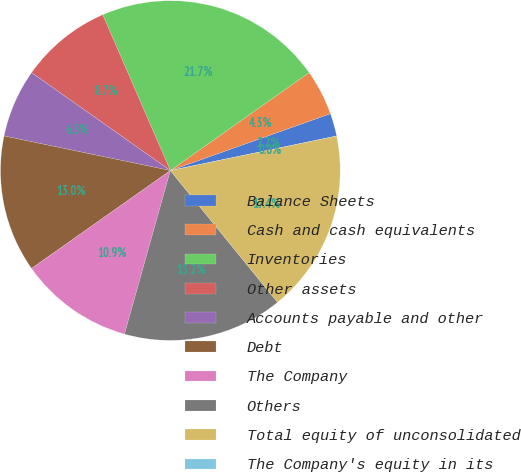<chart> <loc_0><loc_0><loc_500><loc_500><pie_chart><fcel>Balance Sheets<fcel>Cash and cash equivalents<fcel>Inventories<fcel>Other assets<fcel>Accounts payable and other<fcel>Debt<fcel>The Company<fcel>Others<fcel>Total equity of unconsolidated<fcel>The Company's equity in its<nl><fcel>2.17%<fcel>4.35%<fcel>21.74%<fcel>8.7%<fcel>6.52%<fcel>13.04%<fcel>10.87%<fcel>15.22%<fcel>17.39%<fcel>0.0%<nl></chart> 